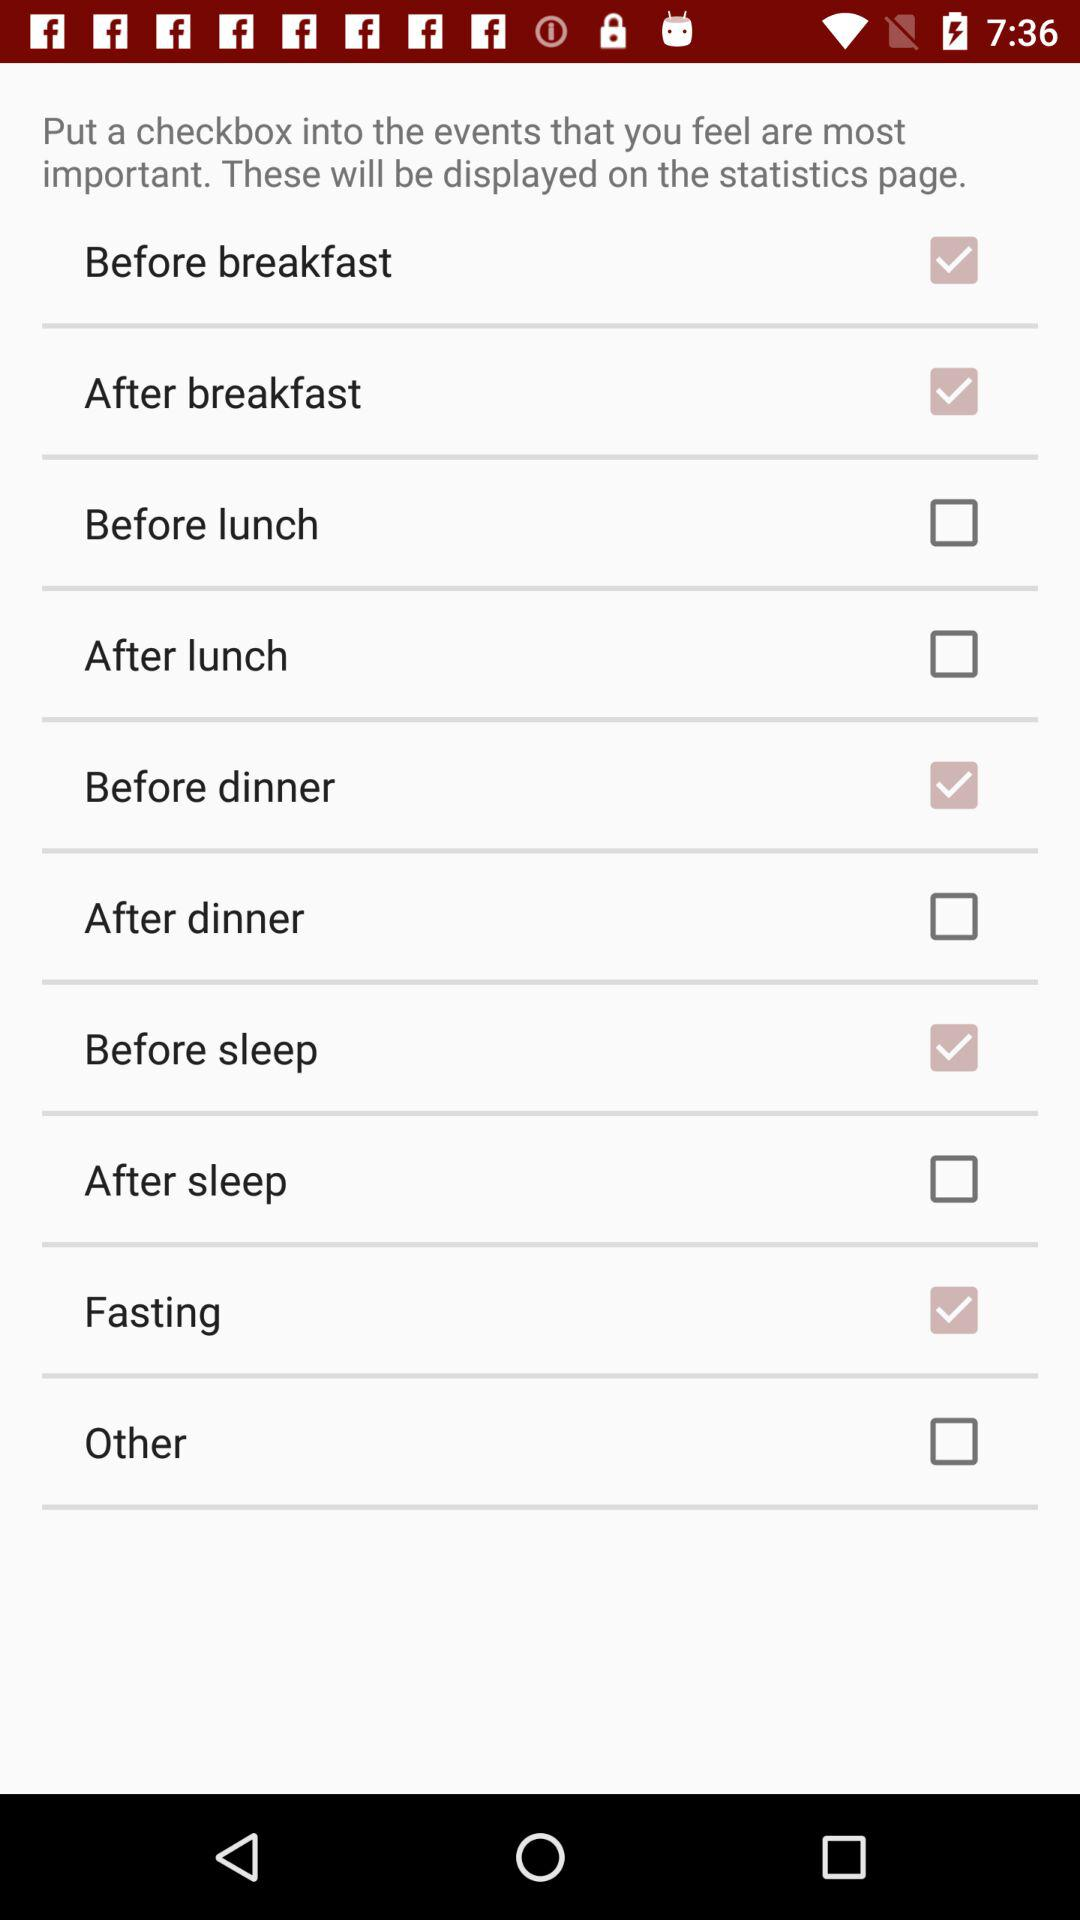What is the current status of "After lunch"? The status is "off". 